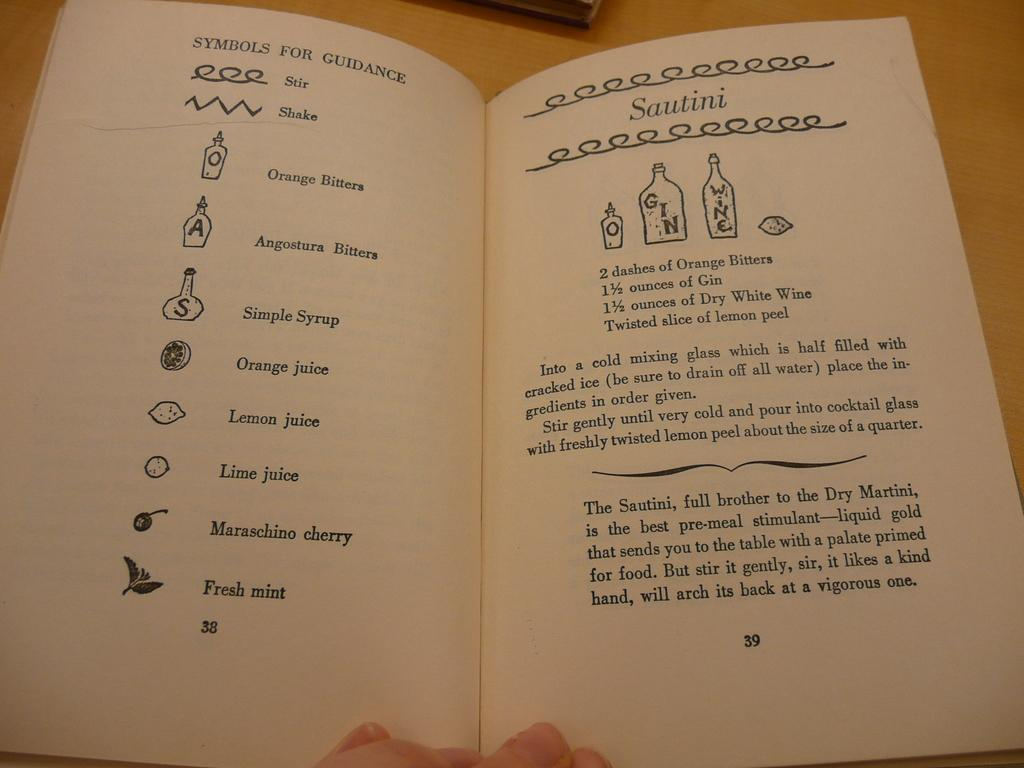<image>
Offer a succinct explanation of the picture presented. A book of cocktail recipes opened to a page with a recipe for a Sautini. 